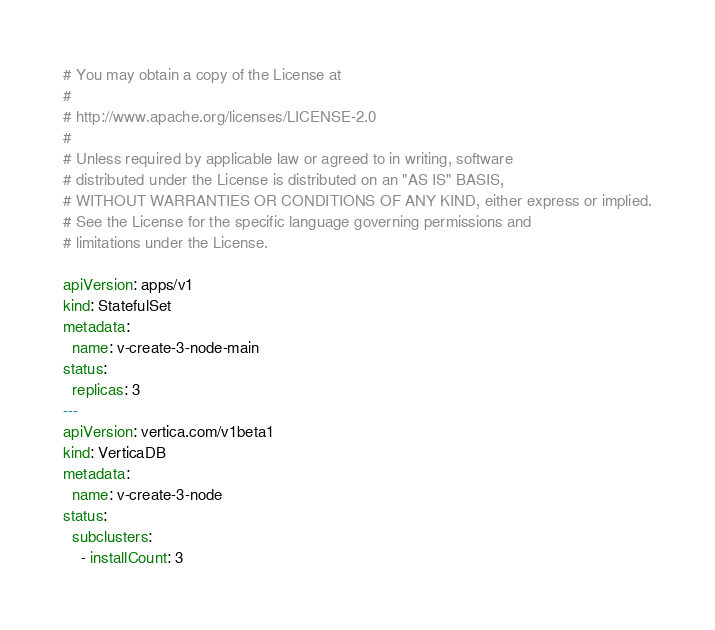<code> <loc_0><loc_0><loc_500><loc_500><_YAML_># You may obtain a copy of the License at
#
# http://www.apache.org/licenses/LICENSE-2.0
#
# Unless required by applicable law or agreed to in writing, software
# distributed under the License is distributed on an "AS IS" BASIS,
# WITHOUT WARRANTIES OR CONDITIONS OF ANY KIND, either express or implied.
# See the License for the specific language governing permissions and
# limitations under the License.

apiVersion: apps/v1
kind: StatefulSet
metadata:
  name: v-create-3-node-main
status:
  replicas: 3
---
apiVersion: vertica.com/v1beta1
kind: VerticaDB
metadata:
  name: v-create-3-node
status:
  subclusters:
    - installCount: 3
</code> 